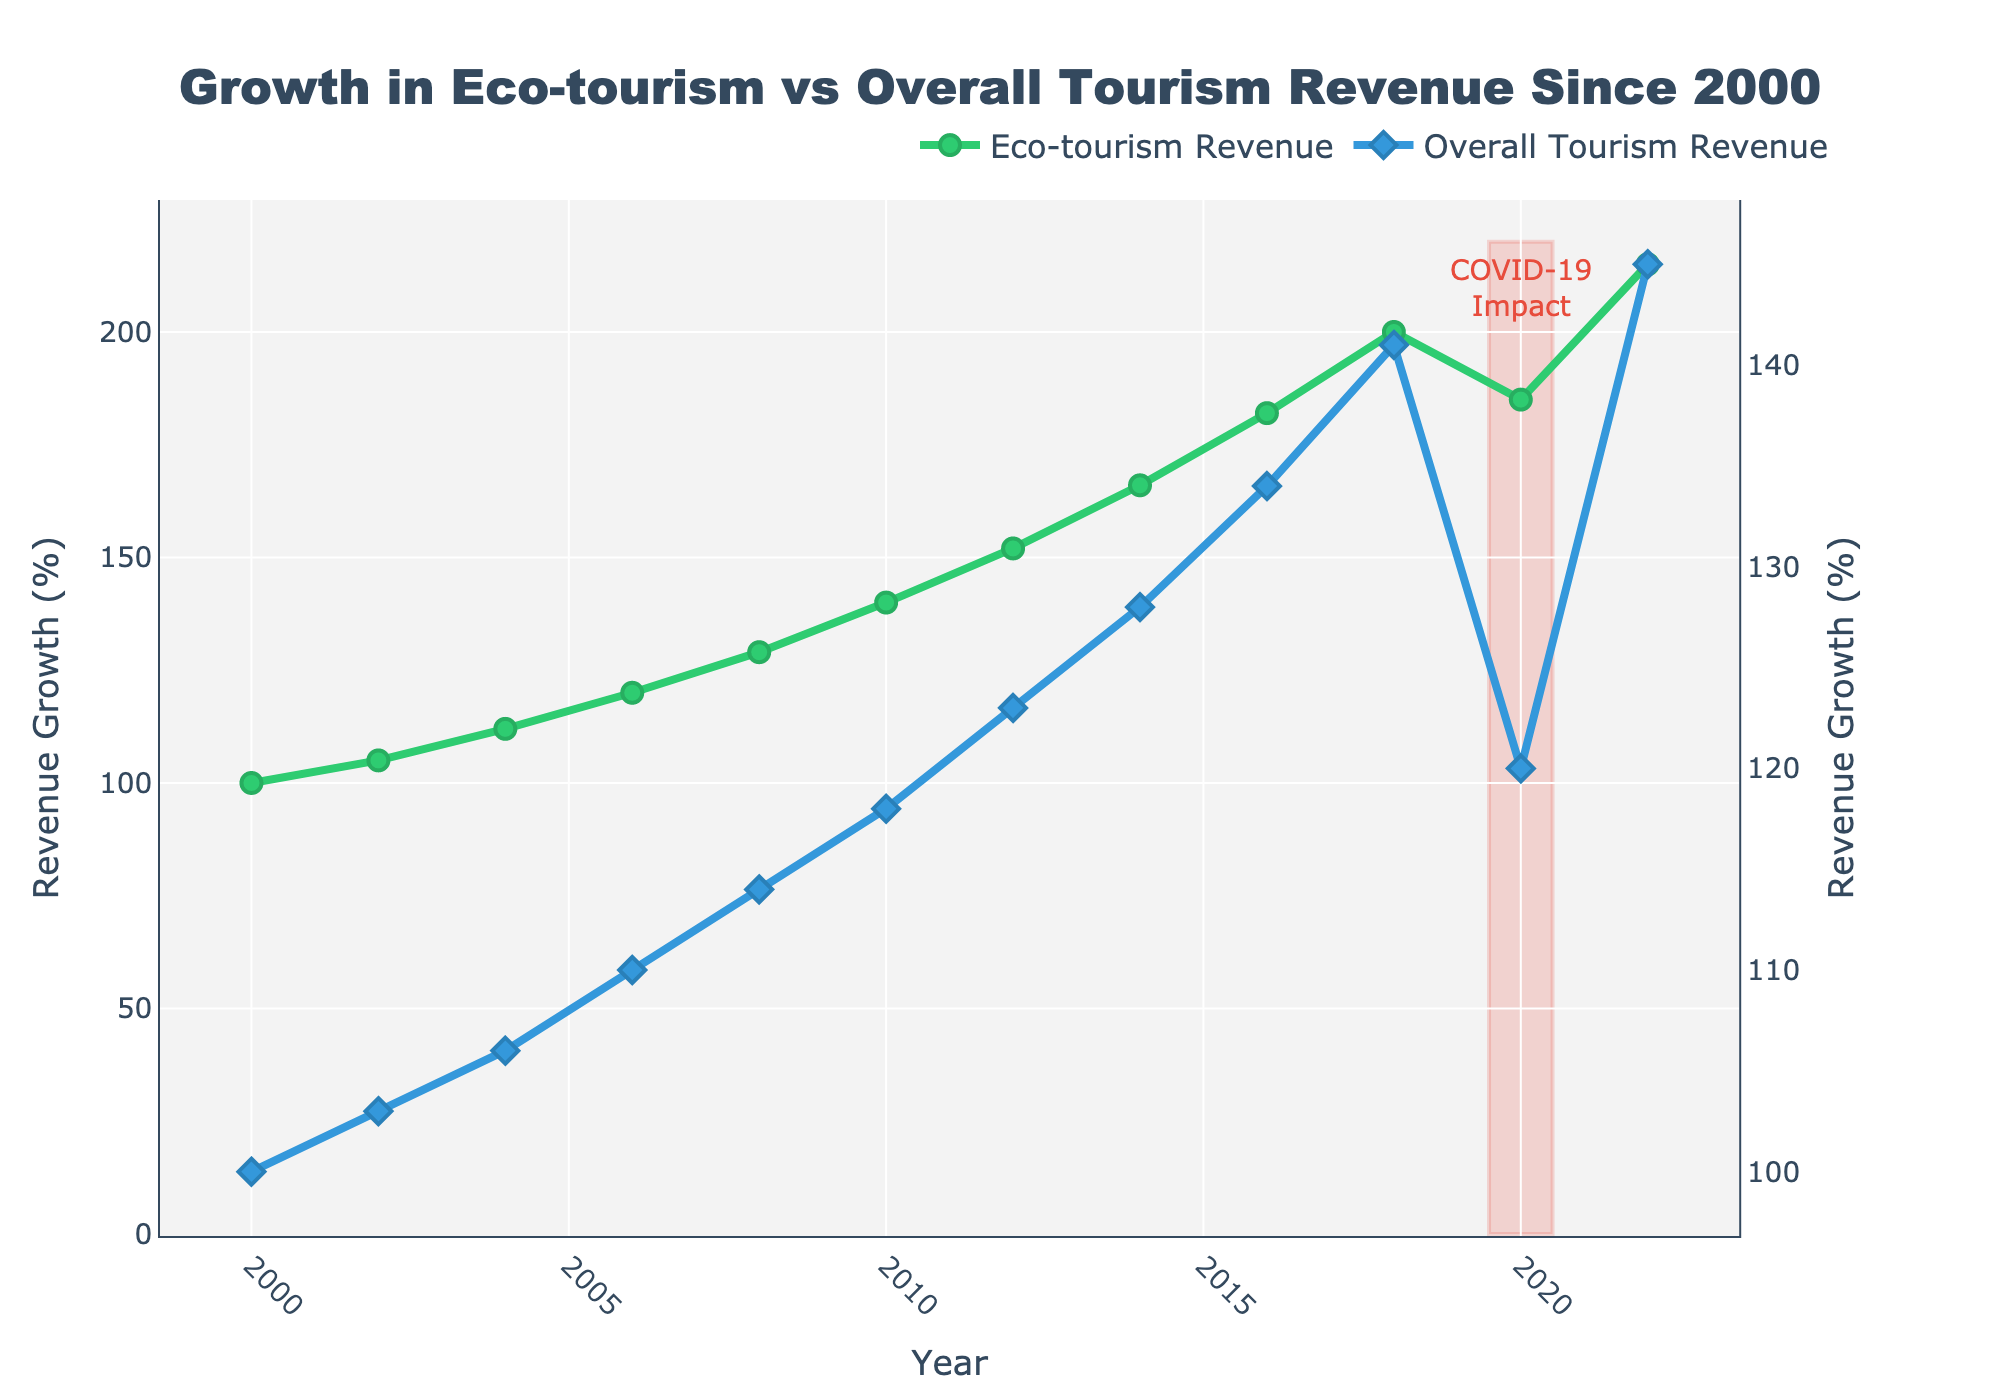What is the overall trend of eco-tourism revenue growth between 2000 and 2022? The eco-tourism revenue shows a consistent increasing trend from 100% in 2000 to 215% in 2022.
Answer: Increasing How does the overall tourism revenue growth compare to the eco-tourism revenue growth in 2020? In 2020, the overall tourism revenue growth is at 120%, while the eco-tourism revenue growth is at 185%, indicating that eco-tourism revenue growth is significantly higher.
Answer: Eco-tourism revenue growth is higher Which year experienced the highest eco-tourism revenue growth? By looking at the line for eco-tourism revenue, the highest value is observed in 2022, where the growth rate reaches 215%.
Answer: 2022 What is the visual difference in marker shapes for eco-tourism and overall tourism revenue? The plot uses circles for eco-tourism revenue markers and diamonds for overall tourism revenue markers.
Answer: Circles for eco-tourism, diamonds for overall tourism During which year(s) is a noticeable dip in eco-tourism revenue observed, and what events might this align with? The noticeable dip in eco-tourism revenue is observed around the year 2020, which aligns with the COVID-19 impact annotated in the plot.
Answer: 2020 How much did eco-tourism revenue grow between 2018 and 2022? In 2018, eco-tourism revenue was at 200%, and in 2022 it reached 215%. The growth between these years is 215% - 200% = 15%.
Answer: 15% Which type of tourism shows more resilience during the COVID-19 period (2019-2020)? By examining the trends during the COVID-19 period, overall tourism revenue significantly drops to lower than previous years, while eco-tourism revenue shows a smaller dip and a quick recovery.
Answer: Eco-tourism Comparing the overall tourism revenue in 2010 to that in 2012, what is the percentage growth? In 2010, the overall tourism revenue is at 118%, and in 2012, it is at 123%. The percentage growth is (123% - 118%) / 118% * 100% ≈ 4.24%.
Answer: Approximately 4.24% Identify the period with the most rapid growth in eco-tourism revenue. The period between 2008 and 2012 shows significant increases, particularly from 129% to 152%, indicating rapid growth.
Answer: 2008-2012 